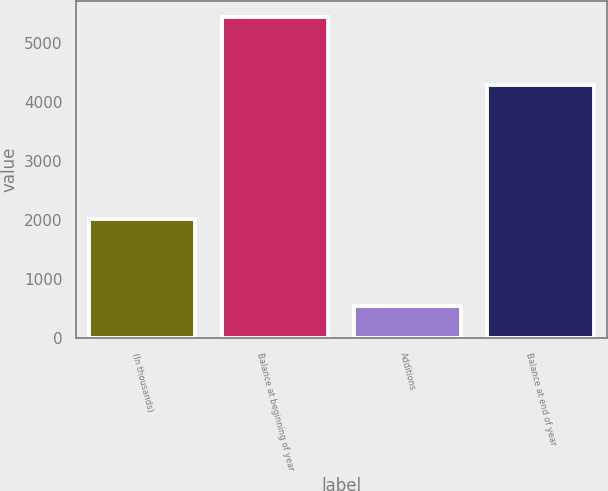Convert chart. <chart><loc_0><loc_0><loc_500><loc_500><bar_chart><fcel>(In thousands)<fcel>Balance at beginning of year<fcel>Additions<fcel>Balance at end of year<nl><fcel>2016<fcel>5448<fcel>542<fcel>4289<nl></chart> 